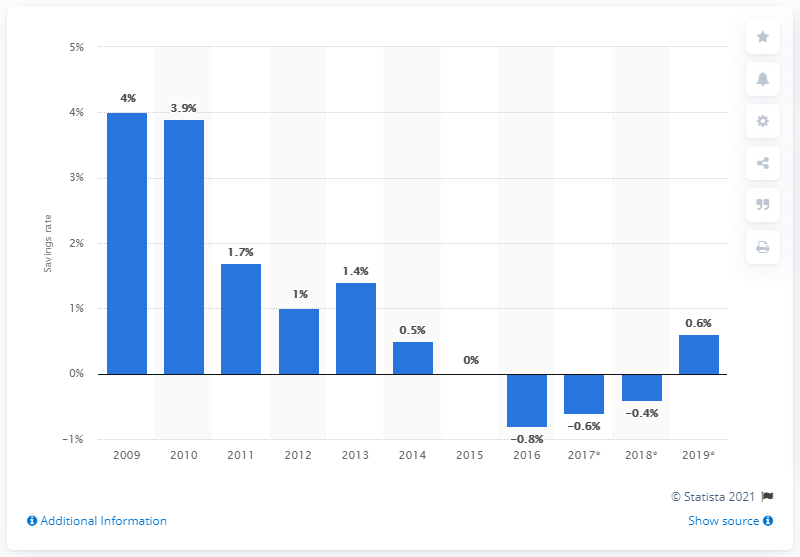Highlight a few significant elements in this photo. During the period of 2009 to 2016, the fluctuation rate of Finland's household savings was relatively stable, with an average variation of 0.6%. In 2019, the household savings rate in Finland was 0.6%. 